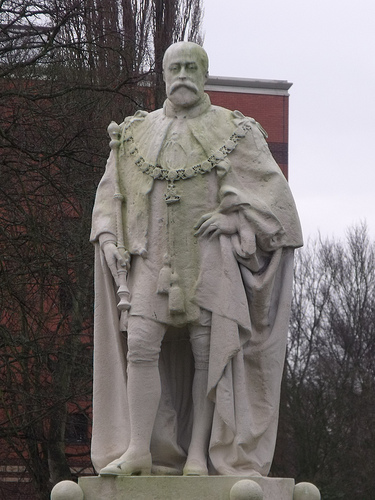<image>
Can you confirm if the statue is under the sky? Yes. The statue is positioned underneath the sky, with the sky above it in the vertical space. 